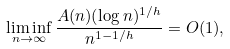Convert formula to latex. <formula><loc_0><loc_0><loc_500><loc_500>\liminf _ { n \to \infty } \frac { A ( n ) ( \log n ) ^ { 1 / h } } { n ^ { 1 - 1 / h } } = O ( 1 ) ,</formula> 